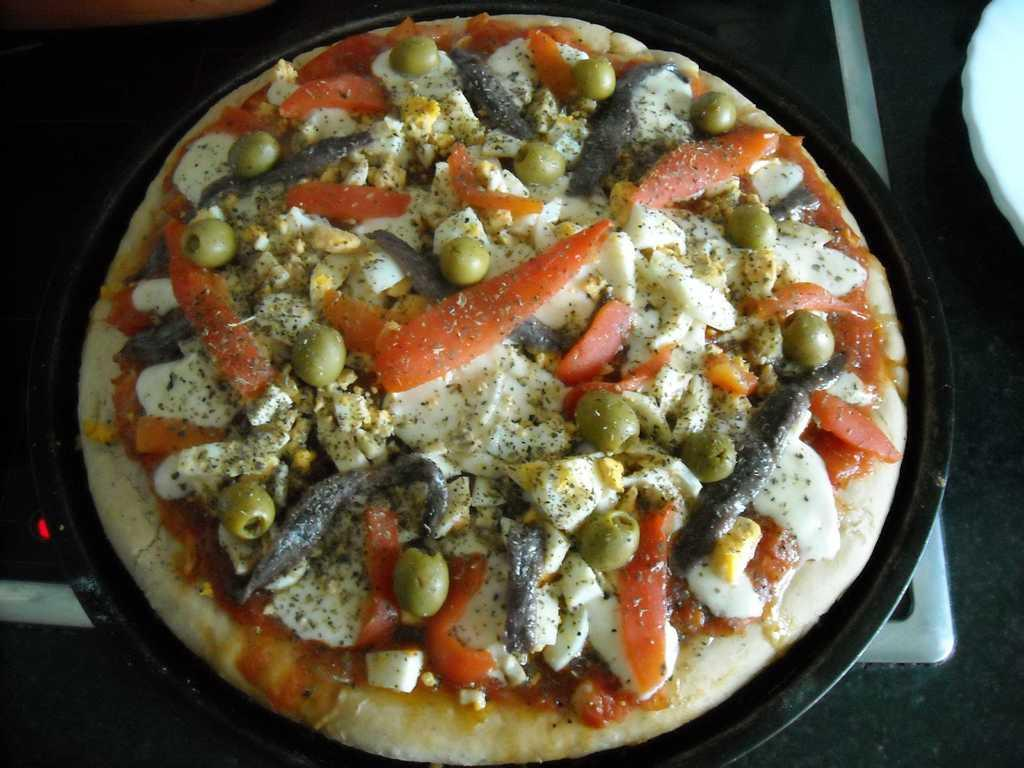What type of food is visible in the image? There is a pizza in the image. How is the pizza being prepared or cooked? The pizza is on a pan, which is on a stove. How does the beginner cook the pizza in the image? There is no indication in the image that the person cooking the pizza is a beginner, and the cooking process is not shown. 